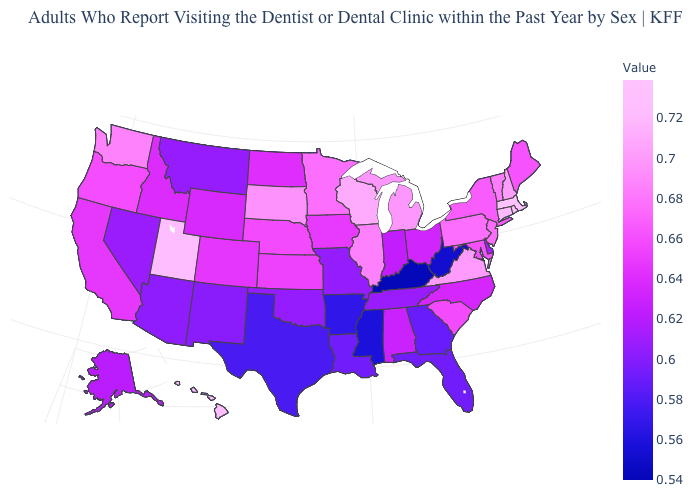Among the states that border Idaho , does Montana have the lowest value?
Quick response, please. Yes. Does New York have a lower value than Michigan?
Be succinct. Yes. Does Washington have the highest value in the West?
Concise answer only. No. Does Wisconsin have the highest value in the USA?
Write a very short answer. No. Among the states that border Wyoming , which have the lowest value?
Concise answer only. Montana. Does Massachusetts have the highest value in the Northeast?
Concise answer only. Yes. 